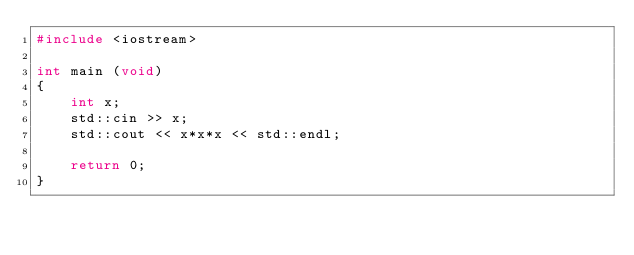<code> <loc_0><loc_0><loc_500><loc_500><_C++_>#include <iostream>

int main (void)
{
	int x;
	std::cin >> x;
	std::cout << x*x*x << std::endl;
	
	return 0;
}</code> 